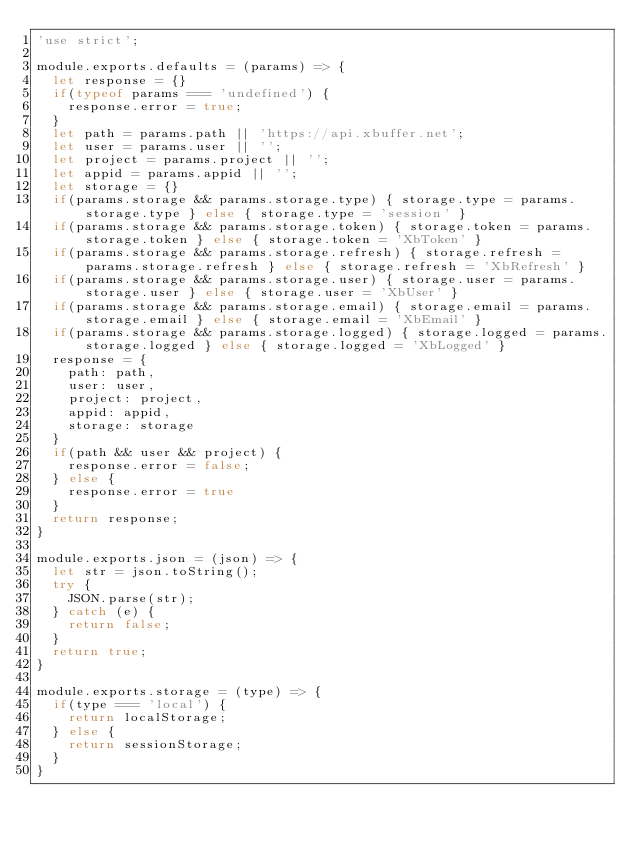<code> <loc_0><loc_0><loc_500><loc_500><_JavaScript_>'use strict';

module.exports.defaults = (params) => {
  let response = {}
  if(typeof params === 'undefined') {
    response.error = true;
  }
  let path = params.path || 'https://api.xbuffer.net';
  let user = params.user || '';
  let project = params.project || '';
  let appid = params.appid || '';
  let storage = {}
  if(params.storage && params.storage.type) { storage.type = params.storage.type } else { storage.type = 'session' }
  if(params.storage && params.storage.token) { storage.token = params.storage.token } else { storage.token = 'XbToken' }
  if(params.storage && params.storage.refresh) { storage.refresh = params.storage.refresh } else { storage.refresh = 'XbRefresh' }
  if(params.storage && params.storage.user) { storage.user = params.storage.user } else { storage.user = 'XbUser' }
  if(params.storage && params.storage.email) { storage.email = params.storage.email } else { storage.email = 'XbEmail' }
  if(params.storage && params.storage.logged) { storage.logged = params.storage.logged } else { storage.logged = 'XbLogged' }
  response = {
    path: path,
    user: user,
    project: project,
    appid: appid,
    storage: storage
  }
  if(path && user && project) {
    response.error = false;
  } else {
    response.error = true
  }
  return response;
}

module.exports.json = (json) => {
  let str = json.toString();
  try {
    JSON.parse(str);
  } catch (e) {
    return false;
  }
  return true;
}

module.exports.storage = (type) => {
  if(type === 'local') {
    return localStorage;
  } else {
    return sessionStorage;
  }
}
</code> 